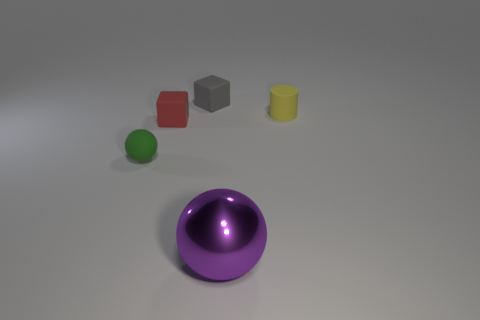How many other objects are there of the same shape as the yellow matte object?
Your response must be concise. 0. What is the small red block made of?
Your answer should be compact. Rubber. There is a thing in front of the green object; what is its material?
Your answer should be very brief. Metal. Is there any other thing that has the same material as the small green ball?
Offer a very short reply. Yes. Are there more small matte things behind the small red rubber block than blue objects?
Offer a terse response. Yes. Are there any yellow matte cylinders that are to the left of the matte thing that is behind the rubber object that is to the right of the purple metallic ball?
Provide a short and direct response. No. Are there any small matte cylinders on the left side of the gray thing?
Keep it short and to the point. No. How many rubber blocks are the same color as the shiny object?
Give a very brief answer. 0. The green thing that is made of the same material as the red cube is what size?
Provide a succinct answer. Small. There is a ball that is in front of the matte thing that is left of the tiny cube in front of the tiny cylinder; how big is it?
Keep it short and to the point. Large. 